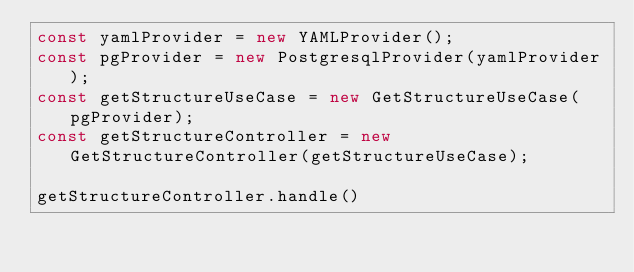Convert code to text. <code><loc_0><loc_0><loc_500><loc_500><_TypeScript_>const yamlProvider = new YAMLProvider();
const pgProvider = new PostgresqlProvider(yamlProvider);
const getStructureUseCase = new GetStructureUseCase(pgProvider);
const getStructureController = new GetStructureController(getStructureUseCase);

getStructureController.handle()
</code> 